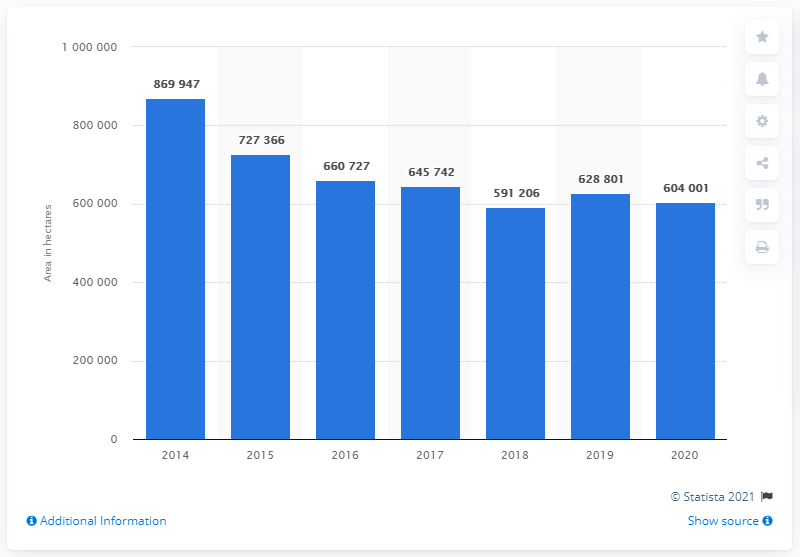Highlight a few significant elements in this photo. In 2020, the total cultivated area in Italy used for the production of corn was 604,001 square kilometers. In 2014, a total of 869,947 hectares of land were cultivated for the production of corn. 